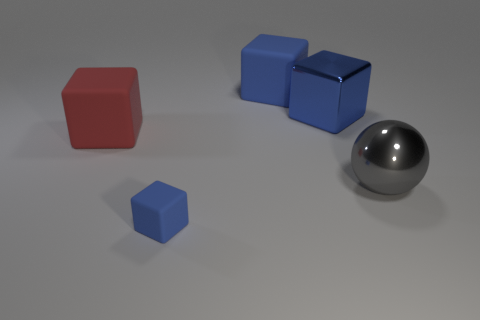What size is the blue shiny thing that is the same shape as the large red thing?
Your answer should be compact. Large. There is a big thing in front of the red rubber cube; what is its shape?
Your answer should be compact. Sphere. There is a blue shiny thing; does it have the same shape as the blue object that is behind the blue metallic cube?
Keep it short and to the point. Yes. Are there the same number of blue objects that are on the left side of the big gray shiny ball and large gray objects in front of the tiny matte thing?
Offer a terse response. No. There is a small matte object that is the same color as the large metallic cube; what shape is it?
Your answer should be compact. Cube. There is a big thing that is behind the big blue metal block; does it have the same color as the small object in front of the big blue metallic block?
Offer a very short reply. Yes. Are there more blue rubber things that are behind the large gray metallic sphere than gray rubber objects?
Offer a terse response. Yes. What is the gray sphere made of?
Provide a short and direct response. Metal. What is the shape of the blue object that is made of the same material as the small block?
Provide a short and direct response. Cube. What size is the metallic thing that is behind the big red matte object left of the gray sphere?
Provide a short and direct response. Large. 